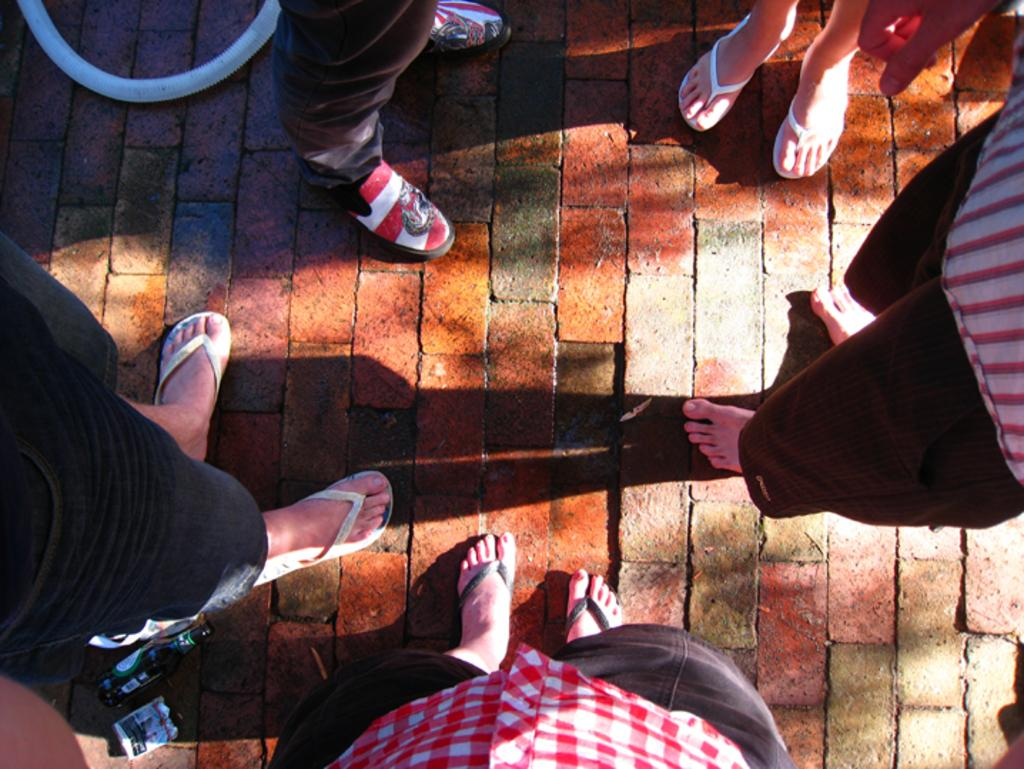How many people are in the image? There is a group of persons standing in the image. What can be seen in the top left corner of the image? There is a pipe in the top left corner of the image. What is the color of the pipe? The pipe is white in color. What type of bells are hanging from the pipe in the image? There are no bells present in the image; only the pipe is visible. 